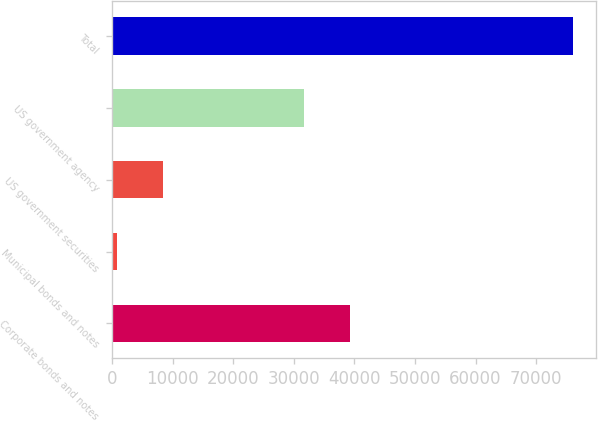<chart> <loc_0><loc_0><loc_500><loc_500><bar_chart><fcel>Corporate bonds and notes<fcel>Municipal bonds and notes<fcel>US government securities<fcel>US government agency<fcel>Total<nl><fcel>39264.3<fcel>881<fcel>8395.3<fcel>31750<fcel>76024<nl></chart> 